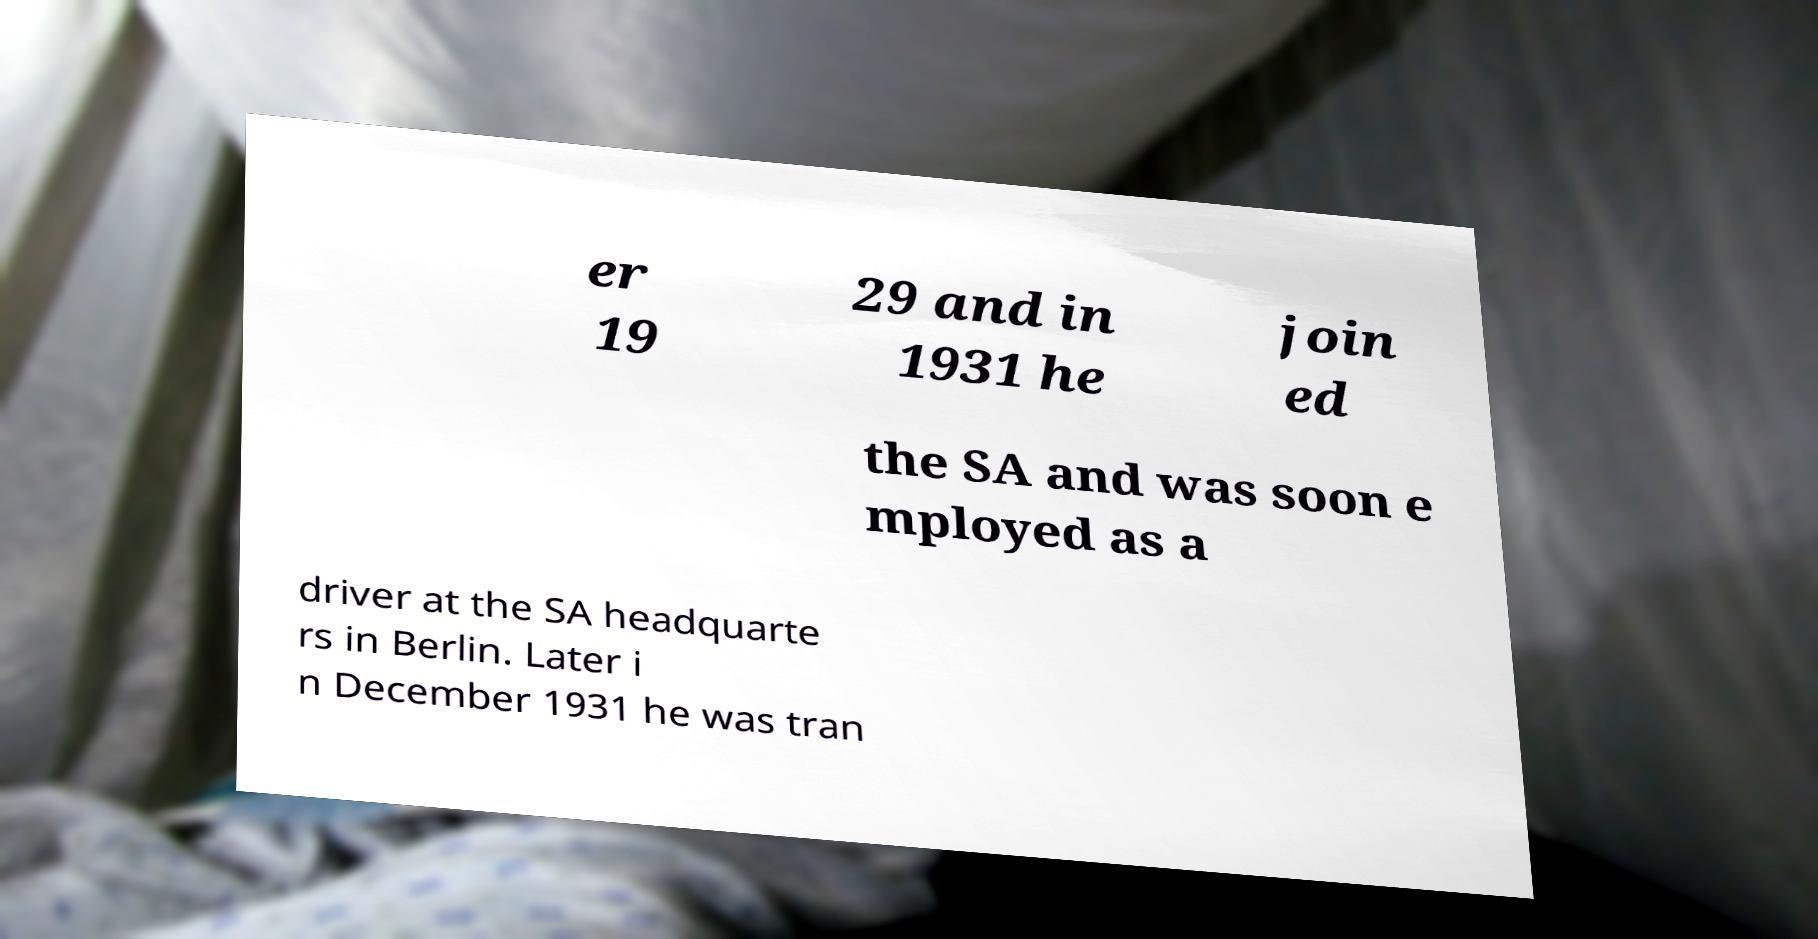Can you accurately transcribe the text from the provided image for me? er 19 29 and in 1931 he join ed the SA and was soon e mployed as a driver at the SA headquarte rs in Berlin. Later i n December 1931 he was tran 